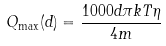Convert formula to latex. <formula><loc_0><loc_0><loc_500><loc_500>Q _ { \max } ( d ) = \frac { 1 0 0 0 d \pi k T \eta } { 4 m }</formula> 